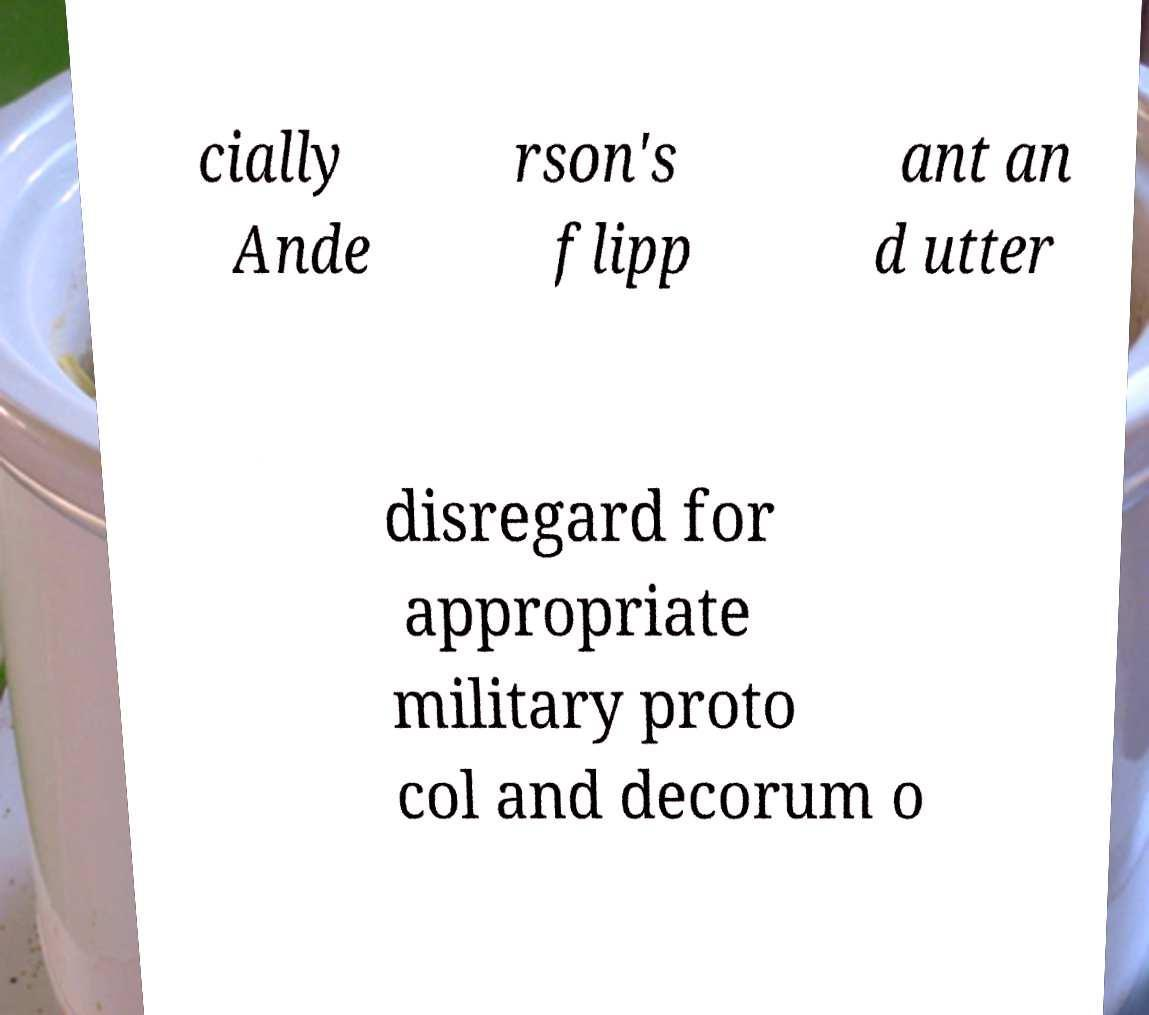For documentation purposes, I need the text within this image transcribed. Could you provide that? cially Ande rson's flipp ant an d utter disregard for appropriate military proto col and decorum o 